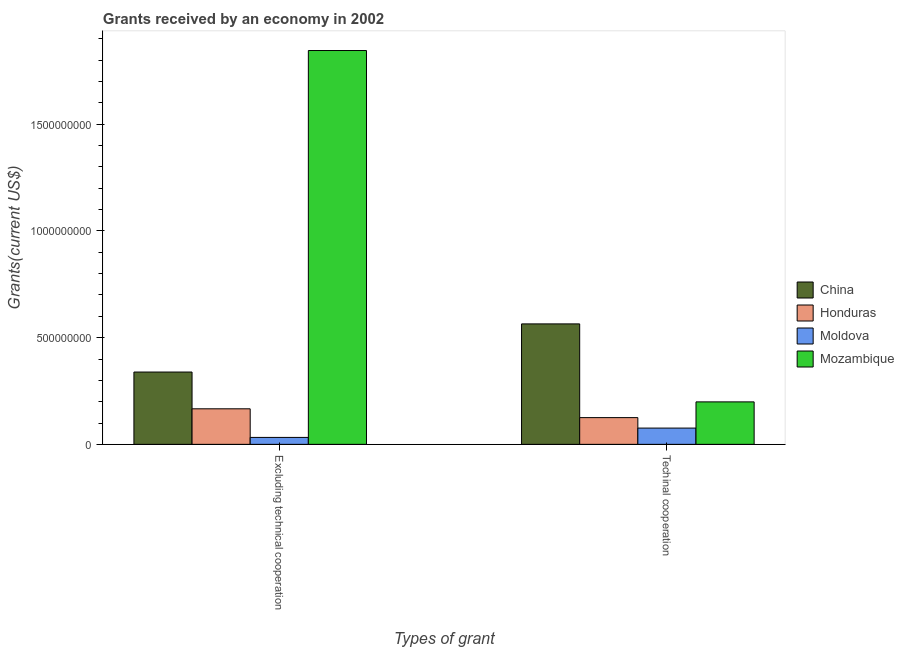How many different coloured bars are there?
Your answer should be very brief. 4. How many groups of bars are there?
Give a very brief answer. 2. Are the number of bars per tick equal to the number of legend labels?
Offer a very short reply. Yes. How many bars are there on the 1st tick from the right?
Make the answer very short. 4. What is the label of the 2nd group of bars from the left?
Give a very brief answer. Techinal cooperation. What is the amount of grants received(excluding technical cooperation) in Mozambique?
Your response must be concise. 1.85e+09. Across all countries, what is the maximum amount of grants received(including technical cooperation)?
Provide a succinct answer. 5.65e+08. Across all countries, what is the minimum amount of grants received(including technical cooperation)?
Your answer should be very brief. 7.62e+07. In which country was the amount of grants received(excluding technical cooperation) maximum?
Ensure brevity in your answer.  Mozambique. In which country was the amount of grants received(excluding technical cooperation) minimum?
Make the answer very short. Moldova. What is the total amount of grants received(including technical cooperation) in the graph?
Provide a short and direct response. 9.65e+08. What is the difference between the amount of grants received(including technical cooperation) in Mozambique and that in Honduras?
Keep it short and to the point. 7.38e+07. What is the difference between the amount of grants received(excluding technical cooperation) in Mozambique and the amount of grants received(including technical cooperation) in Honduras?
Your answer should be very brief. 1.72e+09. What is the average amount of grants received(excluding technical cooperation) per country?
Your answer should be very brief. 5.96e+08. What is the difference between the amount of grants received(excluding technical cooperation) and amount of grants received(including technical cooperation) in Honduras?
Provide a short and direct response. 4.13e+07. What is the ratio of the amount of grants received(including technical cooperation) in China to that in Honduras?
Make the answer very short. 4.51. Is the amount of grants received(excluding technical cooperation) in Mozambique less than that in Honduras?
Keep it short and to the point. No. In how many countries, is the amount of grants received(including technical cooperation) greater than the average amount of grants received(including technical cooperation) taken over all countries?
Ensure brevity in your answer.  1. What does the 4th bar from the left in Excluding technical cooperation represents?
Your answer should be very brief. Mozambique. What does the 2nd bar from the right in Techinal cooperation represents?
Offer a terse response. Moldova. How many bars are there?
Ensure brevity in your answer.  8. Are all the bars in the graph horizontal?
Keep it short and to the point. No. How many countries are there in the graph?
Keep it short and to the point. 4. What is the difference between two consecutive major ticks on the Y-axis?
Keep it short and to the point. 5.00e+08. Does the graph contain grids?
Your answer should be compact. No. What is the title of the graph?
Make the answer very short. Grants received by an economy in 2002. Does "European Union" appear as one of the legend labels in the graph?
Provide a short and direct response. No. What is the label or title of the X-axis?
Provide a succinct answer. Types of grant. What is the label or title of the Y-axis?
Ensure brevity in your answer.  Grants(current US$). What is the Grants(current US$) of China in Excluding technical cooperation?
Make the answer very short. 3.39e+08. What is the Grants(current US$) of Honduras in Excluding technical cooperation?
Ensure brevity in your answer.  1.67e+08. What is the Grants(current US$) in Moldova in Excluding technical cooperation?
Keep it short and to the point. 3.25e+07. What is the Grants(current US$) of Mozambique in Excluding technical cooperation?
Provide a succinct answer. 1.85e+09. What is the Grants(current US$) in China in Techinal cooperation?
Ensure brevity in your answer.  5.65e+08. What is the Grants(current US$) in Honduras in Techinal cooperation?
Make the answer very short. 1.25e+08. What is the Grants(current US$) of Moldova in Techinal cooperation?
Offer a very short reply. 7.62e+07. What is the Grants(current US$) in Mozambique in Techinal cooperation?
Your response must be concise. 1.99e+08. Across all Types of grant, what is the maximum Grants(current US$) in China?
Your answer should be very brief. 5.65e+08. Across all Types of grant, what is the maximum Grants(current US$) in Honduras?
Your answer should be very brief. 1.67e+08. Across all Types of grant, what is the maximum Grants(current US$) of Moldova?
Your answer should be very brief. 7.62e+07. Across all Types of grant, what is the maximum Grants(current US$) of Mozambique?
Ensure brevity in your answer.  1.85e+09. Across all Types of grant, what is the minimum Grants(current US$) of China?
Offer a terse response. 3.39e+08. Across all Types of grant, what is the minimum Grants(current US$) in Honduras?
Provide a succinct answer. 1.25e+08. Across all Types of grant, what is the minimum Grants(current US$) of Moldova?
Provide a short and direct response. 3.25e+07. Across all Types of grant, what is the minimum Grants(current US$) in Mozambique?
Provide a succinct answer. 1.99e+08. What is the total Grants(current US$) in China in the graph?
Keep it short and to the point. 9.03e+08. What is the total Grants(current US$) of Honduras in the graph?
Provide a short and direct response. 2.92e+08. What is the total Grants(current US$) of Moldova in the graph?
Your answer should be compact. 1.09e+08. What is the total Grants(current US$) of Mozambique in the graph?
Make the answer very short. 2.04e+09. What is the difference between the Grants(current US$) of China in Excluding technical cooperation and that in Techinal cooperation?
Make the answer very short. -2.26e+08. What is the difference between the Grants(current US$) of Honduras in Excluding technical cooperation and that in Techinal cooperation?
Your answer should be compact. 4.13e+07. What is the difference between the Grants(current US$) in Moldova in Excluding technical cooperation and that in Techinal cooperation?
Your response must be concise. -4.37e+07. What is the difference between the Grants(current US$) of Mozambique in Excluding technical cooperation and that in Techinal cooperation?
Give a very brief answer. 1.65e+09. What is the difference between the Grants(current US$) of China in Excluding technical cooperation and the Grants(current US$) of Honduras in Techinal cooperation?
Keep it short and to the point. 2.14e+08. What is the difference between the Grants(current US$) in China in Excluding technical cooperation and the Grants(current US$) in Moldova in Techinal cooperation?
Make the answer very short. 2.63e+08. What is the difference between the Grants(current US$) of China in Excluding technical cooperation and the Grants(current US$) of Mozambique in Techinal cooperation?
Make the answer very short. 1.40e+08. What is the difference between the Grants(current US$) in Honduras in Excluding technical cooperation and the Grants(current US$) in Moldova in Techinal cooperation?
Your response must be concise. 9.04e+07. What is the difference between the Grants(current US$) in Honduras in Excluding technical cooperation and the Grants(current US$) in Mozambique in Techinal cooperation?
Offer a very short reply. -3.24e+07. What is the difference between the Grants(current US$) of Moldova in Excluding technical cooperation and the Grants(current US$) of Mozambique in Techinal cooperation?
Offer a very short reply. -1.67e+08. What is the average Grants(current US$) in China per Types of grant?
Offer a terse response. 4.52e+08. What is the average Grants(current US$) in Honduras per Types of grant?
Make the answer very short. 1.46e+08. What is the average Grants(current US$) of Moldova per Types of grant?
Your response must be concise. 5.44e+07. What is the average Grants(current US$) of Mozambique per Types of grant?
Offer a terse response. 1.02e+09. What is the difference between the Grants(current US$) of China and Grants(current US$) of Honduras in Excluding technical cooperation?
Provide a succinct answer. 1.72e+08. What is the difference between the Grants(current US$) of China and Grants(current US$) of Moldova in Excluding technical cooperation?
Make the answer very short. 3.06e+08. What is the difference between the Grants(current US$) in China and Grants(current US$) in Mozambique in Excluding technical cooperation?
Your response must be concise. -1.51e+09. What is the difference between the Grants(current US$) of Honduras and Grants(current US$) of Moldova in Excluding technical cooperation?
Your answer should be very brief. 1.34e+08. What is the difference between the Grants(current US$) of Honduras and Grants(current US$) of Mozambique in Excluding technical cooperation?
Your response must be concise. -1.68e+09. What is the difference between the Grants(current US$) in Moldova and Grants(current US$) in Mozambique in Excluding technical cooperation?
Provide a short and direct response. -1.81e+09. What is the difference between the Grants(current US$) in China and Grants(current US$) in Honduras in Techinal cooperation?
Provide a succinct answer. 4.39e+08. What is the difference between the Grants(current US$) in China and Grants(current US$) in Moldova in Techinal cooperation?
Your answer should be very brief. 4.88e+08. What is the difference between the Grants(current US$) in China and Grants(current US$) in Mozambique in Techinal cooperation?
Give a very brief answer. 3.65e+08. What is the difference between the Grants(current US$) in Honduras and Grants(current US$) in Moldova in Techinal cooperation?
Give a very brief answer. 4.91e+07. What is the difference between the Grants(current US$) in Honduras and Grants(current US$) in Mozambique in Techinal cooperation?
Make the answer very short. -7.38e+07. What is the difference between the Grants(current US$) in Moldova and Grants(current US$) in Mozambique in Techinal cooperation?
Keep it short and to the point. -1.23e+08. What is the ratio of the Grants(current US$) in China in Excluding technical cooperation to that in Techinal cooperation?
Keep it short and to the point. 0.6. What is the ratio of the Grants(current US$) in Honduras in Excluding technical cooperation to that in Techinal cooperation?
Your response must be concise. 1.33. What is the ratio of the Grants(current US$) in Moldova in Excluding technical cooperation to that in Techinal cooperation?
Offer a very short reply. 0.43. What is the ratio of the Grants(current US$) in Mozambique in Excluding technical cooperation to that in Techinal cooperation?
Offer a very short reply. 9.27. What is the difference between the highest and the second highest Grants(current US$) of China?
Your answer should be compact. 2.26e+08. What is the difference between the highest and the second highest Grants(current US$) in Honduras?
Ensure brevity in your answer.  4.13e+07. What is the difference between the highest and the second highest Grants(current US$) in Moldova?
Offer a terse response. 4.37e+07. What is the difference between the highest and the second highest Grants(current US$) of Mozambique?
Provide a succinct answer. 1.65e+09. What is the difference between the highest and the lowest Grants(current US$) of China?
Your response must be concise. 2.26e+08. What is the difference between the highest and the lowest Grants(current US$) of Honduras?
Your answer should be compact. 4.13e+07. What is the difference between the highest and the lowest Grants(current US$) of Moldova?
Give a very brief answer. 4.37e+07. What is the difference between the highest and the lowest Grants(current US$) of Mozambique?
Provide a succinct answer. 1.65e+09. 